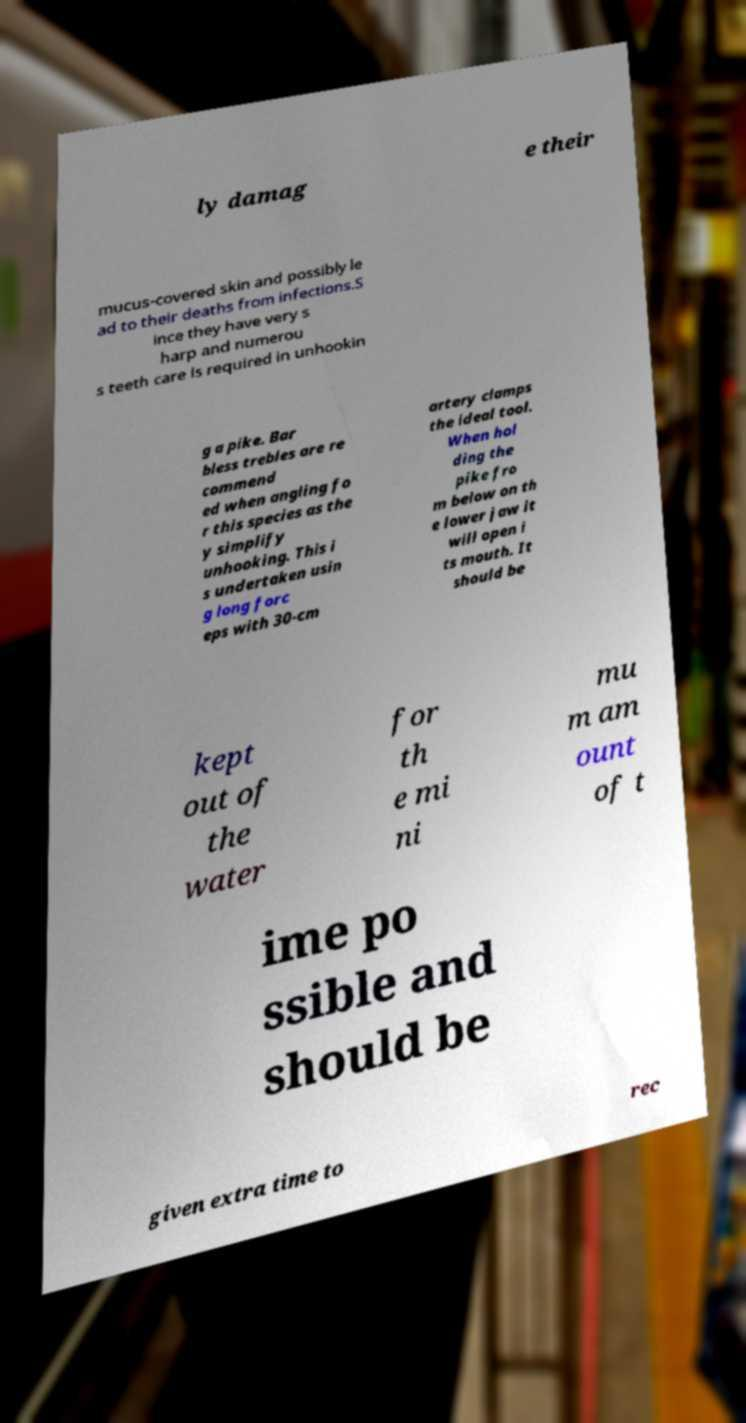For documentation purposes, I need the text within this image transcribed. Could you provide that? ly damag e their mucus-covered skin and possibly le ad to their deaths from infections.S ince they have very s harp and numerou s teeth care is required in unhookin g a pike. Bar bless trebles are re commend ed when angling fo r this species as the y simplify unhooking. This i s undertaken usin g long forc eps with 30-cm artery clamps the ideal tool. When hol ding the pike fro m below on th e lower jaw it will open i ts mouth. It should be kept out of the water for th e mi ni mu m am ount of t ime po ssible and should be given extra time to rec 